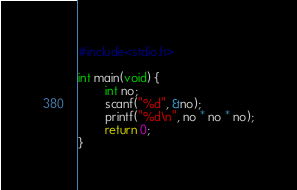Convert code to text. <code><loc_0><loc_0><loc_500><loc_500><_C_>#include<stdio.h>

int main(void) {
        int no;
        scanf("%d", &no);
        printf("%d\n", no * no * no);
        return 0;
}</code> 